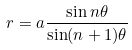<formula> <loc_0><loc_0><loc_500><loc_500>r = a \frac { \sin n \theta } { \sin ( n + 1 ) \theta }</formula> 